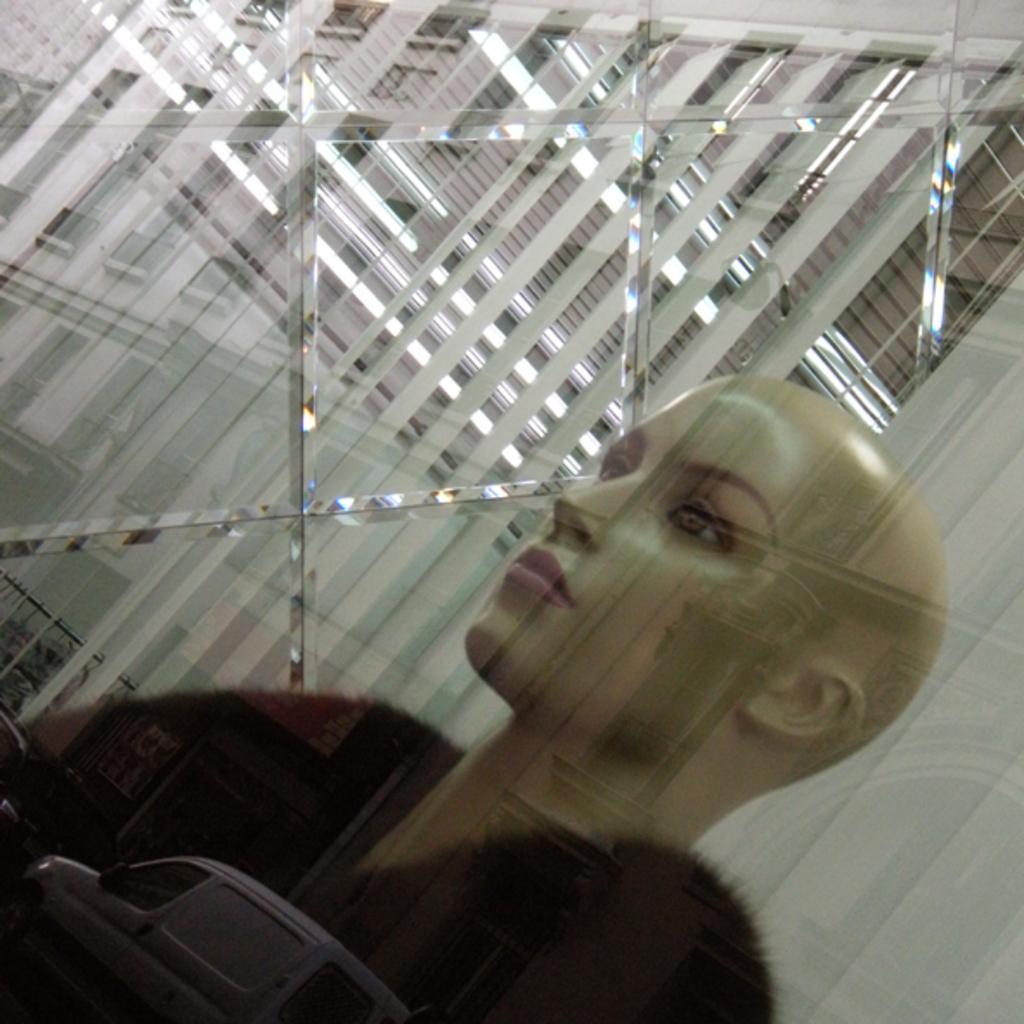How would you summarize this image in a sentence or two? In the foreground of this image, there is a mannequin inside the glass and in the reflection, there is a vehicle moving on the road and the wall of a building and in the background, there is a window blind. 